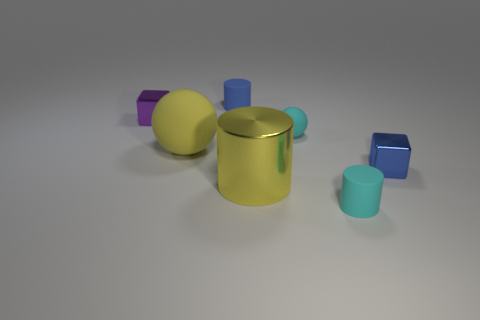Add 3 yellow matte spheres. How many objects exist? 10 Subtract all blocks. How many objects are left? 5 Add 2 small cyan cylinders. How many small cyan cylinders are left? 3 Add 6 metallic cubes. How many metallic cubes exist? 8 Subtract 0 gray cubes. How many objects are left? 7 Subtract all tiny blue metal objects. Subtract all big rubber things. How many objects are left? 5 